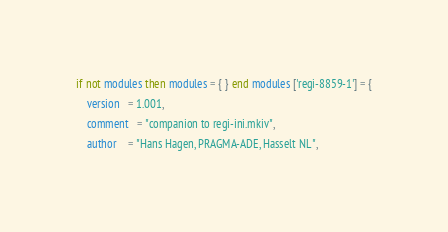Convert code to text. <code><loc_0><loc_0><loc_500><loc_500><_Lua_>if not modules then modules = { } end modules ['regi-8859-1'] = {
    version   = 1.001,
    comment   = "companion to regi-ini.mkiv",
    author    = "Hans Hagen, PRAGMA-ADE, Hasselt NL",</code> 